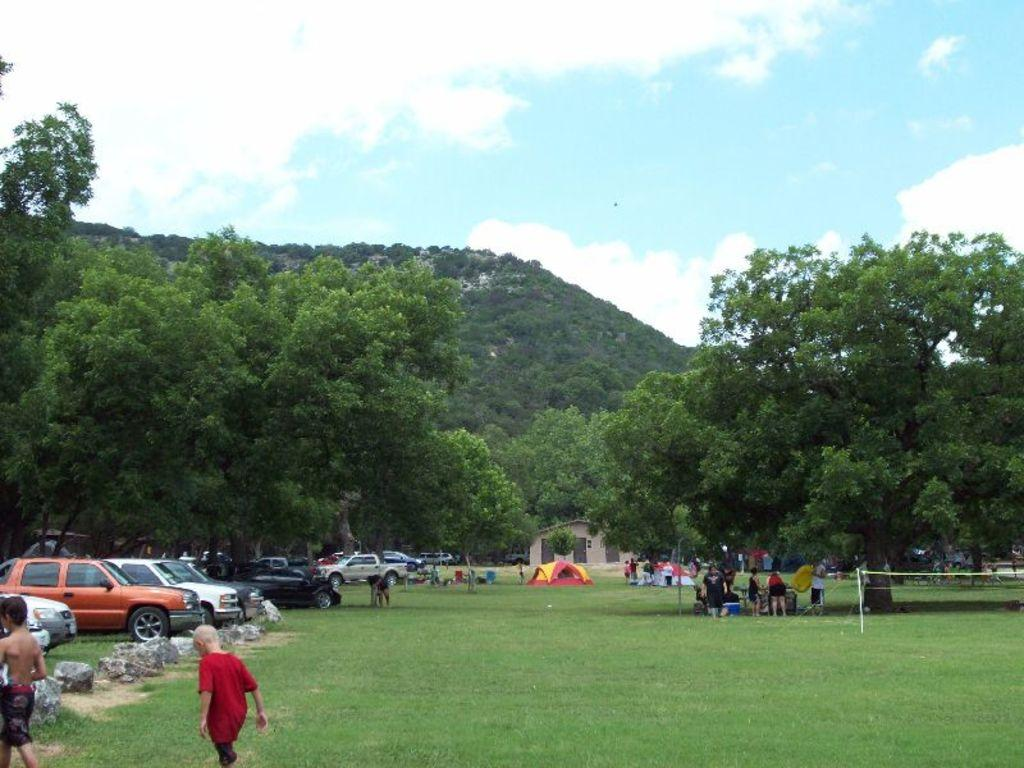What type of vegetation can be seen in the image? There is grass in the image. What type of vehicles are present in the image? There are cars in the image. Are there any human figures in the image? Yes, there are people in the image. What type of building can be seen in the image? There is a house in the image. What other natural elements are visible in the image? There are trees in the image. What is visible in the sky in the image? The sky is visible in the image, and clouds are also visible. What color is the silverware used by the ducks in the image? There are no ducks or silverware present in the image. How many people believe in the existence of the house in the image? The image does not provide information about people's beliefs regarding the house. 